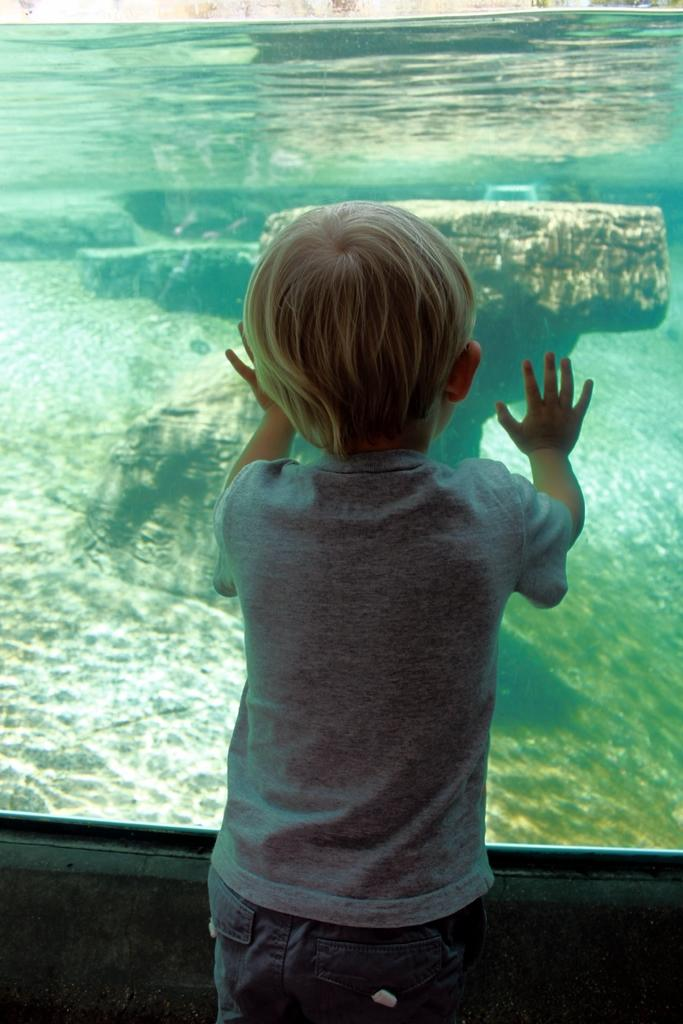What is the main subject of the picture? The main subject of the picture is a child. Where is the child located in relation to the water? The child is standing near the water. What can be seen in the water? There are stones present in the water. What type of grain is being harvested by the writer in the image? There is no writer or grain present in the image; it features a child standing near the water with stones in it. 